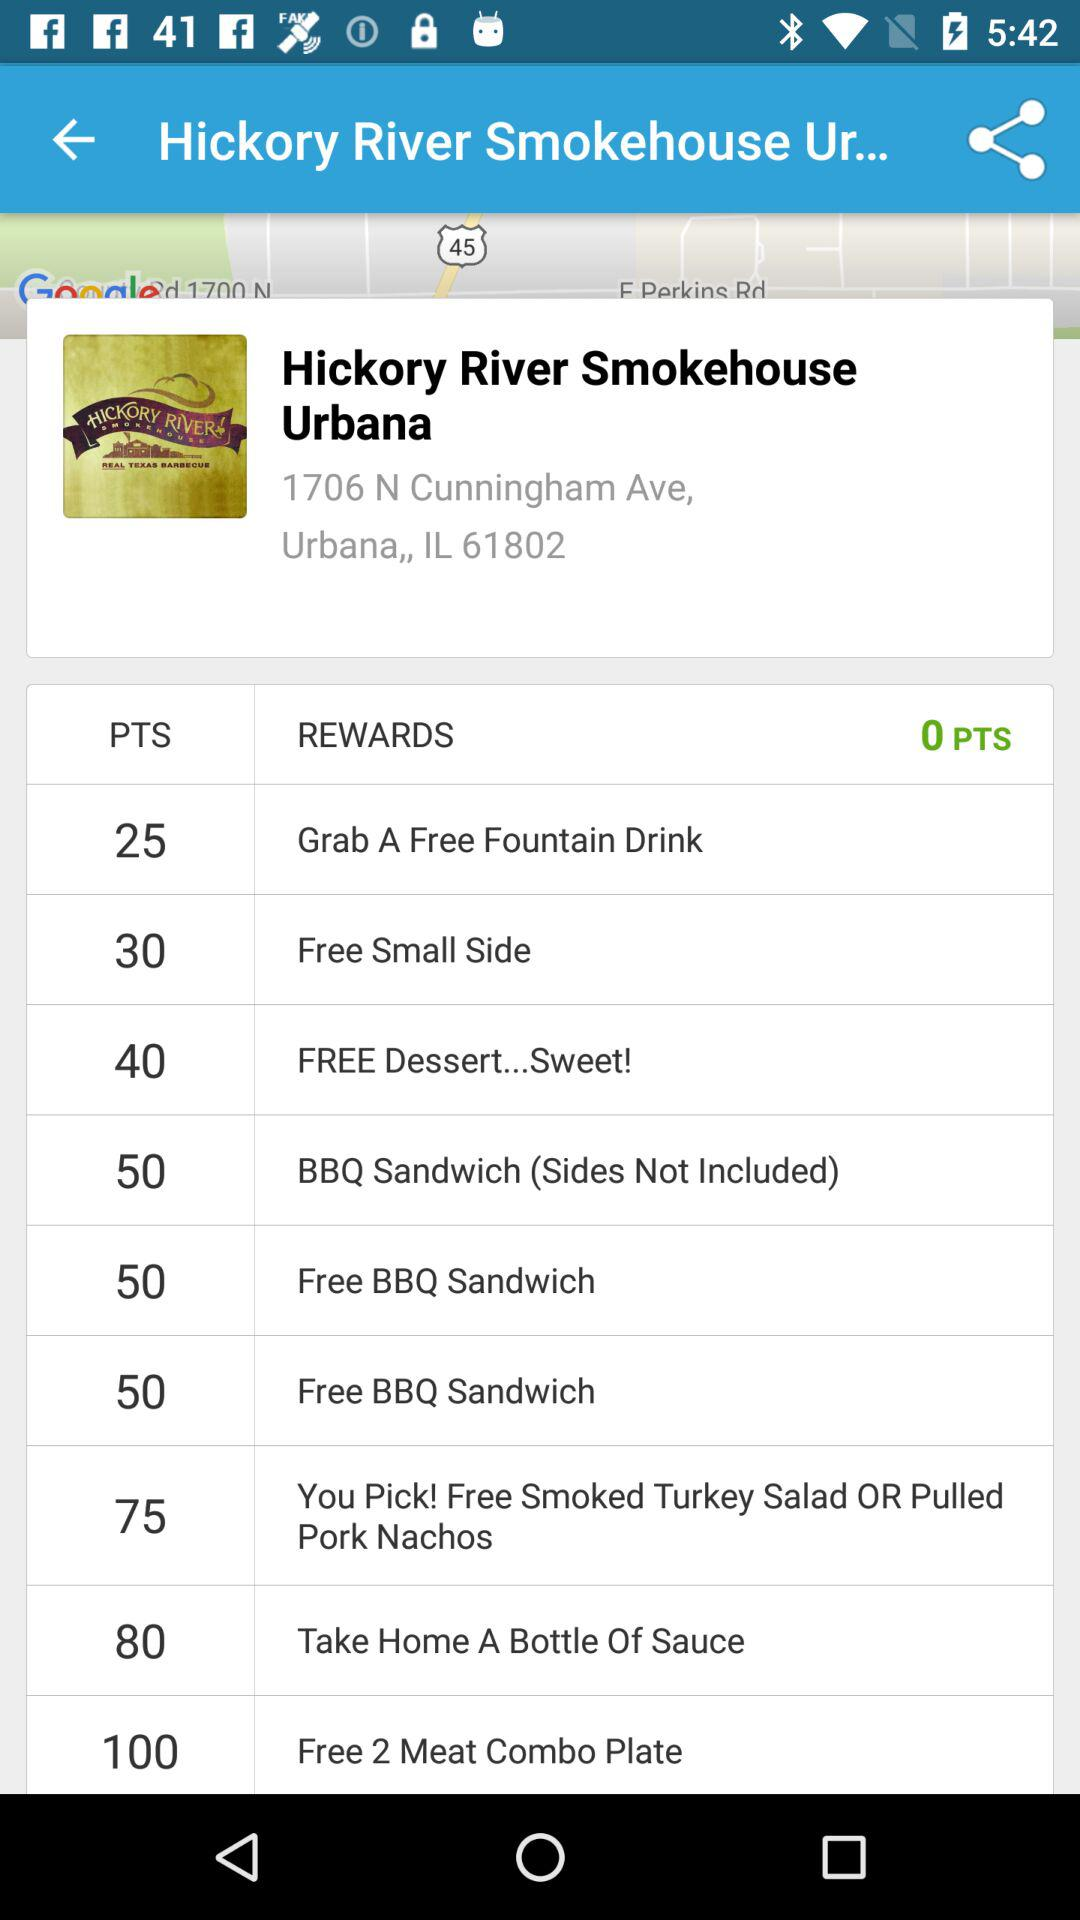Which reward has the maximum number of points?
When the provided information is insufficient, respond with <no answer>. <no answer> 